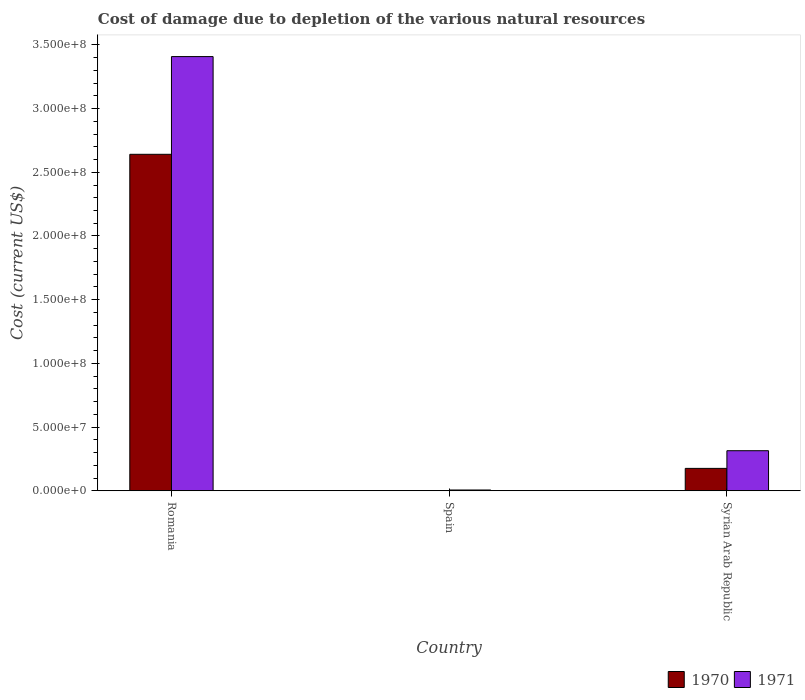How many different coloured bars are there?
Keep it short and to the point. 2. How many groups of bars are there?
Your response must be concise. 3. Are the number of bars per tick equal to the number of legend labels?
Your answer should be compact. Yes. Are the number of bars on each tick of the X-axis equal?
Provide a succinct answer. Yes. How many bars are there on the 2nd tick from the left?
Make the answer very short. 2. How many bars are there on the 2nd tick from the right?
Your response must be concise. 2. What is the label of the 3rd group of bars from the left?
Your answer should be compact. Syrian Arab Republic. In how many cases, is the number of bars for a given country not equal to the number of legend labels?
Offer a very short reply. 0. What is the cost of damage caused due to the depletion of various natural resources in 1970 in Spain?
Offer a terse response. 1.78e+04. Across all countries, what is the maximum cost of damage caused due to the depletion of various natural resources in 1971?
Offer a terse response. 3.41e+08. Across all countries, what is the minimum cost of damage caused due to the depletion of various natural resources in 1971?
Offer a terse response. 6.25e+05. In which country was the cost of damage caused due to the depletion of various natural resources in 1970 maximum?
Keep it short and to the point. Romania. In which country was the cost of damage caused due to the depletion of various natural resources in 1970 minimum?
Your answer should be very brief. Spain. What is the total cost of damage caused due to the depletion of various natural resources in 1971 in the graph?
Your response must be concise. 3.73e+08. What is the difference between the cost of damage caused due to the depletion of various natural resources in 1971 in Romania and that in Syrian Arab Republic?
Ensure brevity in your answer.  3.09e+08. What is the difference between the cost of damage caused due to the depletion of various natural resources in 1971 in Syrian Arab Republic and the cost of damage caused due to the depletion of various natural resources in 1970 in Romania?
Give a very brief answer. -2.33e+08. What is the average cost of damage caused due to the depletion of various natural resources in 1971 per country?
Offer a terse response. 1.24e+08. What is the difference between the cost of damage caused due to the depletion of various natural resources of/in 1971 and cost of damage caused due to the depletion of various natural resources of/in 1970 in Spain?
Your answer should be compact. 6.07e+05. In how many countries, is the cost of damage caused due to the depletion of various natural resources in 1970 greater than 30000000 US$?
Provide a short and direct response. 1. What is the ratio of the cost of damage caused due to the depletion of various natural resources in 1971 in Romania to that in Spain?
Offer a terse response. 545.26. Is the cost of damage caused due to the depletion of various natural resources in 1970 in Romania less than that in Spain?
Offer a terse response. No. What is the difference between the highest and the second highest cost of damage caused due to the depletion of various natural resources in 1970?
Offer a terse response. -2.64e+08. What is the difference between the highest and the lowest cost of damage caused due to the depletion of various natural resources in 1970?
Provide a succinct answer. 2.64e+08. What does the 2nd bar from the left in Syrian Arab Republic represents?
Your answer should be compact. 1971. What is the difference between two consecutive major ticks on the Y-axis?
Offer a terse response. 5.00e+07. Does the graph contain any zero values?
Make the answer very short. No. How are the legend labels stacked?
Offer a terse response. Horizontal. What is the title of the graph?
Give a very brief answer. Cost of damage due to depletion of the various natural resources. What is the label or title of the Y-axis?
Your answer should be compact. Cost (current US$). What is the Cost (current US$) in 1970 in Romania?
Offer a very short reply. 2.64e+08. What is the Cost (current US$) in 1971 in Romania?
Give a very brief answer. 3.41e+08. What is the Cost (current US$) of 1970 in Spain?
Give a very brief answer. 1.78e+04. What is the Cost (current US$) of 1971 in Spain?
Offer a very short reply. 6.25e+05. What is the Cost (current US$) in 1970 in Syrian Arab Republic?
Keep it short and to the point. 1.76e+07. What is the Cost (current US$) of 1971 in Syrian Arab Republic?
Keep it short and to the point. 3.14e+07. Across all countries, what is the maximum Cost (current US$) in 1970?
Ensure brevity in your answer.  2.64e+08. Across all countries, what is the maximum Cost (current US$) of 1971?
Make the answer very short. 3.41e+08. Across all countries, what is the minimum Cost (current US$) of 1970?
Provide a succinct answer. 1.78e+04. Across all countries, what is the minimum Cost (current US$) of 1971?
Offer a very short reply. 6.25e+05. What is the total Cost (current US$) of 1970 in the graph?
Keep it short and to the point. 2.82e+08. What is the total Cost (current US$) of 1971 in the graph?
Make the answer very short. 3.73e+08. What is the difference between the Cost (current US$) of 1970 in Romania and that in Spain?
Keep it short and to the point. 2.64e+08. What is the difference between the Cost (current US$) of 1971 in Romania and that in Spain?
Offer a terse response. 3.40e+08. What is the difference between the Cost (current US$) of 1970 in Romania and that in Syrian Arab Republic?
Your answer should be very brief. 2.47e+08. What is the difference between the Cost (current US$) of 1971 in Romania and that in Syrian Arab Republic?
Ensure brevity in your answer.  3.09e+08. What is the difference between the Cost (current US$) in 1970 in Spain and that in Syrian Arab Republic?
Offer a very short reply. -1.76e+07. What is the difference between the Cost (current US$) of 1971 in Spain and that in Syrian Arab Republic?
Provide a short and direct response. -3.08e+07. What is the difference between the Cost (current US$) of 1970 in Romania and the Cost (current US$) of 1971 in Spain?
Make the answer very short. 2.63e+08. What is the difference between the Cost (current US$) in 1970 in Romania and the Cost (current US$) in 1971 in Syrian Arab Republic?
Keep it short and to the point. 2.33e+08. What is the difference between the Cost (current US$) of 1970 in Spain and the Cost (current US$) of 1971 in Syrian Arab Republic?
Your answer should be very brief. -3.14e+07. What is the average Cost (current US$) of 1970 per country?
Ensure brevity in your answer.  9.39e+07. What is the average Cost (current US$) in 1971 per country?
Your answer should be compact. 1.24e+08. What is the difference between the Cost (current US$) in 1970 and Cost (current US$) in 1971 in Romania?
Provide a short and direct response. -7.67e+07. What is the difference between the Cost (current US$) of 1970 and Cost (current US$) of 1971 in Spain?
Give a very brief answer. -6.07e+05. What is the difference between the Cost (current US$) in 1970 and Cost (current US$) in 1971 in Syrian Arab Republic?
Offer a terse response. -1.39e+07. What is the ratio of the Cost (current US$) of 1970 in Romania to that in Spain?
Make the answer very short. 1.48e+04. What is the ratio of the Cost (current US$) of 1971 in Romania to that in Spain?
Ensure brevity in your answer.  545.26. What is the ratio of the Cost (current US$) of 1970 in Romania to that in Syrian Arab Republic?
Offer a very short reply. 15.02. What is the ratio of the Cost (current US$) of 1971 in Romania to that in Syrian Arab Republic?
Ensure brevity in your answer.  10.84. What is the ratio of the Cost (current US$) in 1970 in Spain to that in Syrian Arab Republic?
Provide a succinct answer. 0. What is the ratio of the Cost (current US$) in 1971 in Spain to that in Syrian Arab Republic?
Offer a terse response. 0.02. What is the difference between the highest and the second highest Cost (current US$) in 1970?
Your answer should be very brief. 2.47e+08. What is the difference between the highest and the second highest Cost (current US$) in 1971?
Make the answer very short. 3.09e+08. What is the difference between the highest and the lowest Cost (current US$) in 1970?
Give a very brief answer. 2.64e+08. What is the difference between the highest and the lowest Cost (current US$) in 1971?
Ensure brevity in your answer.  3.40e+08. 